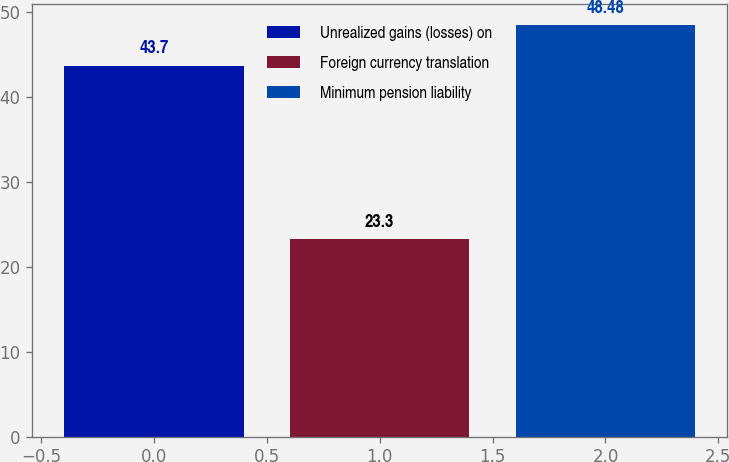<chart> <loc_0><loc_0><loc_500><loc_500><bar_chart><fcel>Unrealized gains (losses) on<fcel>Foreign currency translation<fcel>Minimum pension liability<nl><fcel>43.7<fcel>23.3<fcel>48.48<nl></chart> 